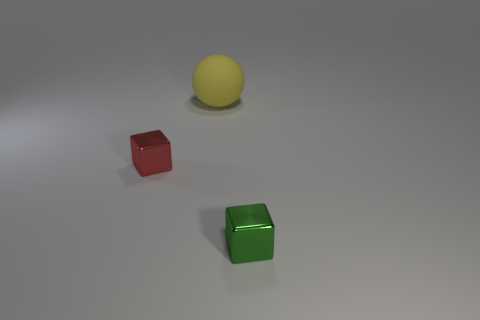Add 3 red shiny things. How many objects exist? 6 Subtract all cubes. How many objects are left? 1 Subtract all small green rubber things. Subtract all red metallic blocks. How many objects are left? 2 Add 1 red metal cubes. How many red metal cubes are left? 2 Add 2 spheres. How many spheres exist? 3 Subtract 0 purple spheres. How many objects are left? 3 